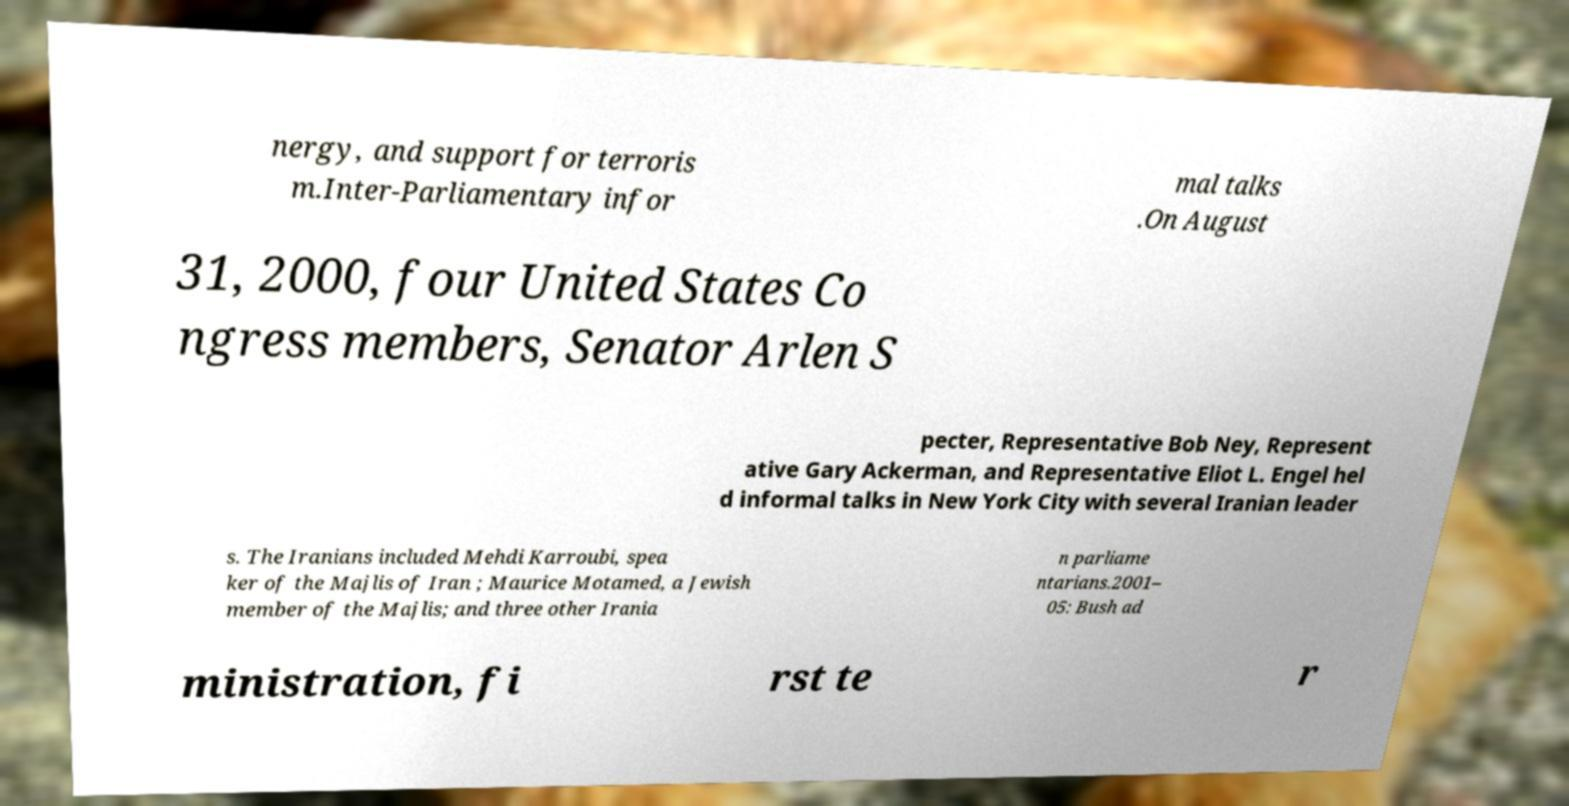What messages or text are displayed in this image? I need them in a readable, typed format. nergy, and support for terroris m.Inter-Parliamentary infor mal talks .On August 31, 2000, four United States Co ngress members, Senator Arlen S pecter, Representative Bob Ney, Represent ative Gary Ackerman, and Representative Eliot L. Engel hel d informal talks in New York City with several Iranian leader s. The Iranians included Mehdi Karroubi, spea ker of the Majlis of Iran ; Maurice Motamed, a Jewish member of the Majlis; and three other Irania n parliame ntarians.2001– 05: Bush ad ministration, fi rst te r 